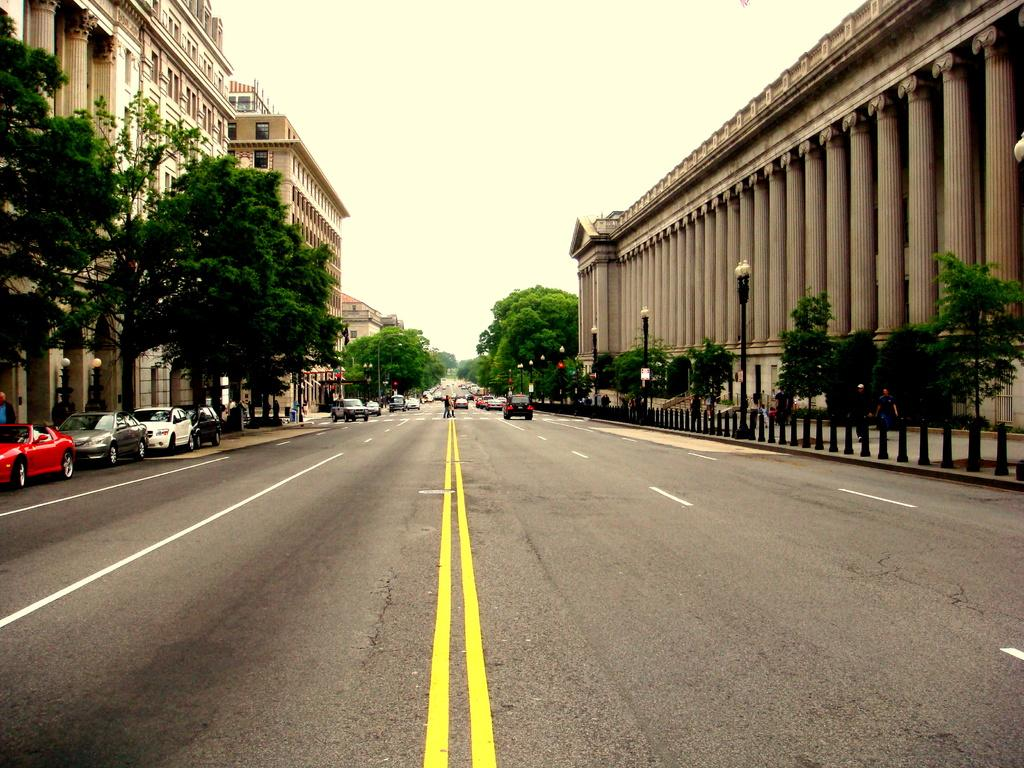What is happening on the road in the image? There are vehicles and people on the road in the image. What can be seen in the background of the image? There are trees, buildings, divider cones, lights, and poles in the background of the image. What is visible at the top of the image? The sky is visible at the top of the image. What type of discovery was made at the school in the image? There is no school present in the image, so no discovery can be made in this context. Can you describe the hill in the image? There is no hill present in the image; it features a road with vehicles and people, along with various background elements. 